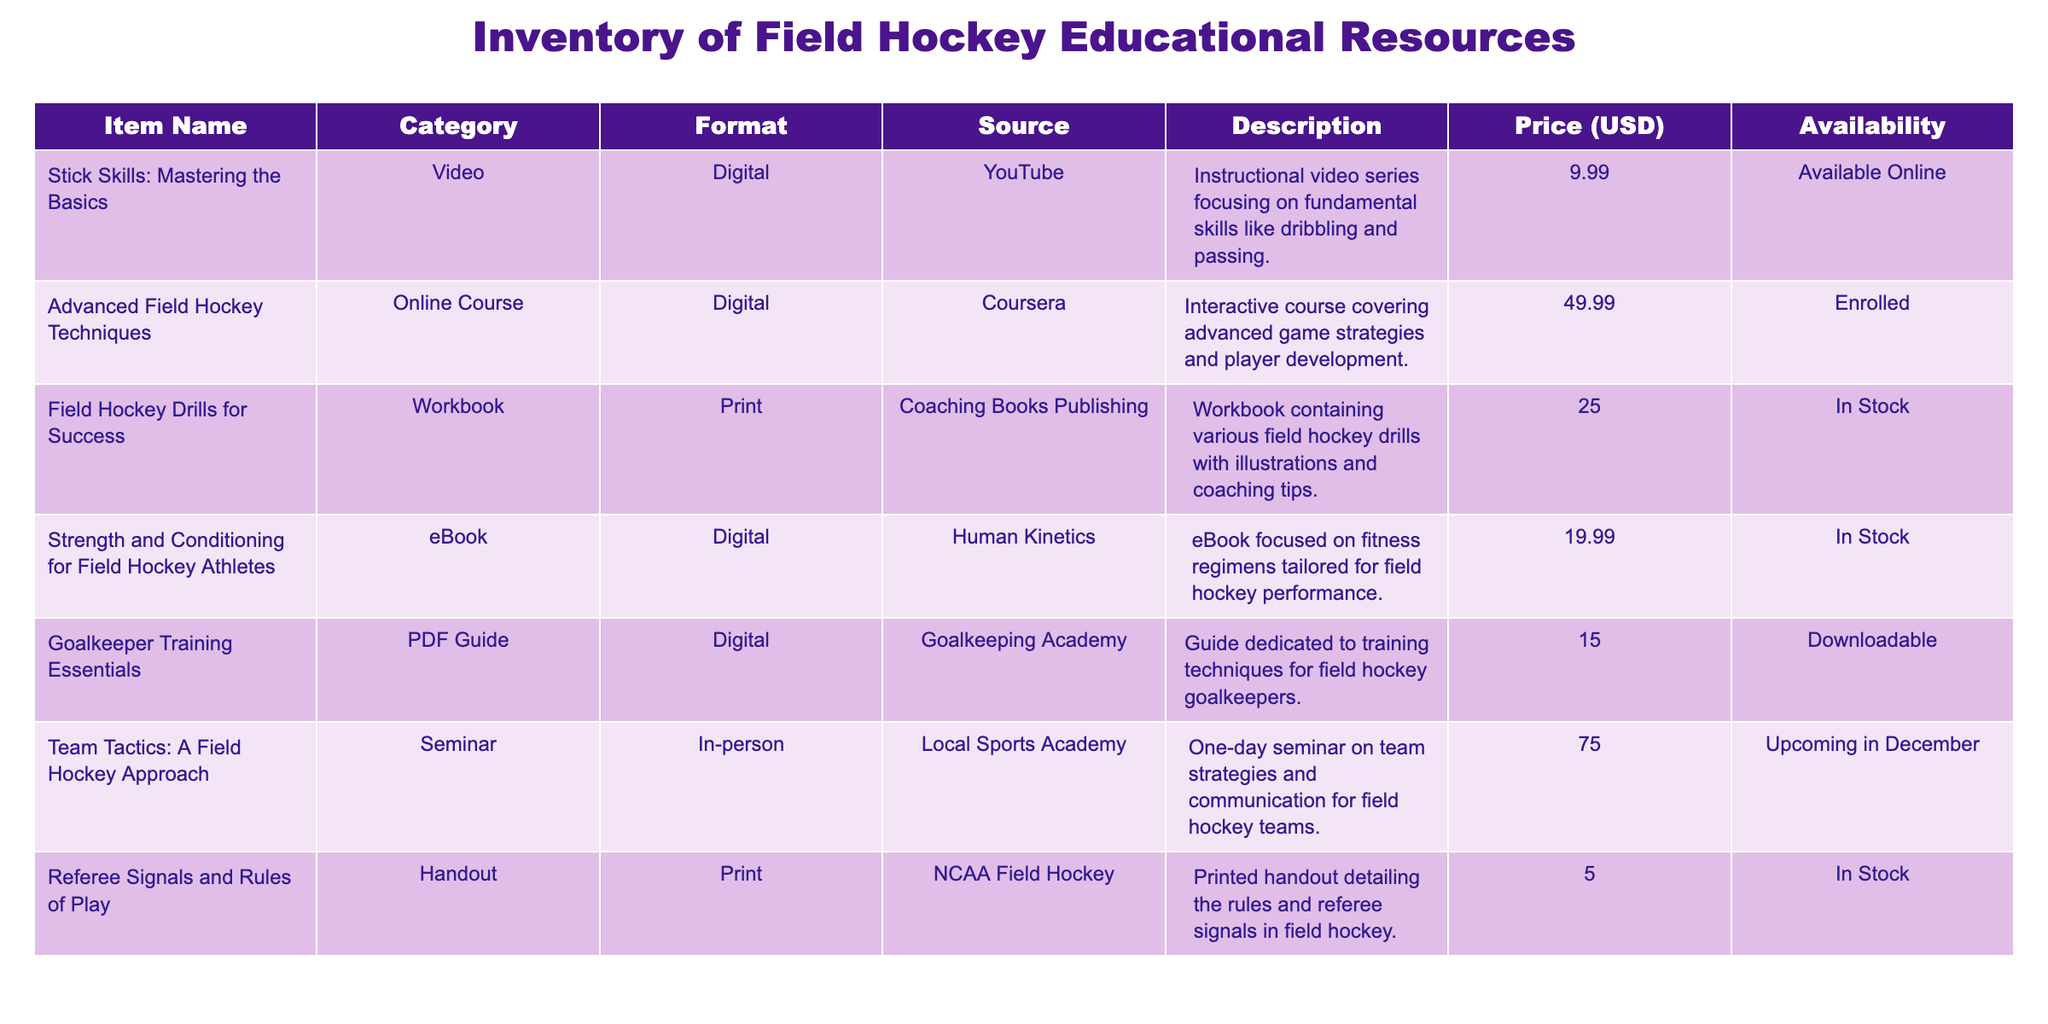What is the price of the "Strength and Conditioning for Field Hockey Athletes" eBook? The price for the "Strength and Conditioning for Field Hockey Athletes" eBook is listed directly in the table under the "Price (USD)" column, corresponding to the specific item name. It is stated as 19.99 USD.
Answer: 19.99 Is the "Goalkeeper Training Essentials" guide available for download? The availability for the "Goalkeeper Training Essentials" guide is found in the "Availability" column of the table. It is noted as "Downloadable," indicating that it is indeed available for download.
Answer: Yes How many items in the inventory are available in print format? I can check the "Format" column for the inventory. The items listed as "Print" are "Field Hockey Drills for Success" and "Referee Signals and Rules of Play," which totals to 2 print format items.
Answer: 2 What is the total cost of the online resources available? The online resources are "Advanced Field Hockey Techniques," "Stick Skills: Mastering the Basics," and "Strength and Conditioning for Field Hockey Athletes." Their prices are 49.99, 9.99, and 19.99 USD respectively. Adding these together gives a total of (49.99 + 9.99 + 19.99) = 79.97 USD for online resources.
Answer: 79.97 Is there an item related to team tactics in the inventory? By reviewing the "Description" column, we can see that "Team Tactics: A Field Hockey Approach" is listed, which is directly related to team tactics. Therefore, the answer is based on the presence of this item.
Answer: Yes Which item is the most expensive, and what is its price? To find the most expensive item, I will check the "Price (USD)" column for the highest value. The "Team Tactics: A Field Hockey Approach" is priced at 75.00 USD, which is the highest compared to all other items on the list.
Answer: 75.00 What percentage of the total items are currently in stock? There are 7 items listed in total. The items marked as "In Stock" are "Field Hockey Drills for Success," "Strength and Conditioning for Field Hockey Athletes," and "Referee Signals and Rules of Play," totaling 3. The percentage is calculated as (3/7) * 100 = 42.86%.
Answer: 42.86% Are there any digital resources costing less than 15 USD? I will check the "Price (USD)" for all items listed under "Digital" format. The only digital item below 15 USD is "Goalkeeper Training Essentials," priced at 15.00 USD. Since it’s not less than 15, the answer is negative.
Answer: No 